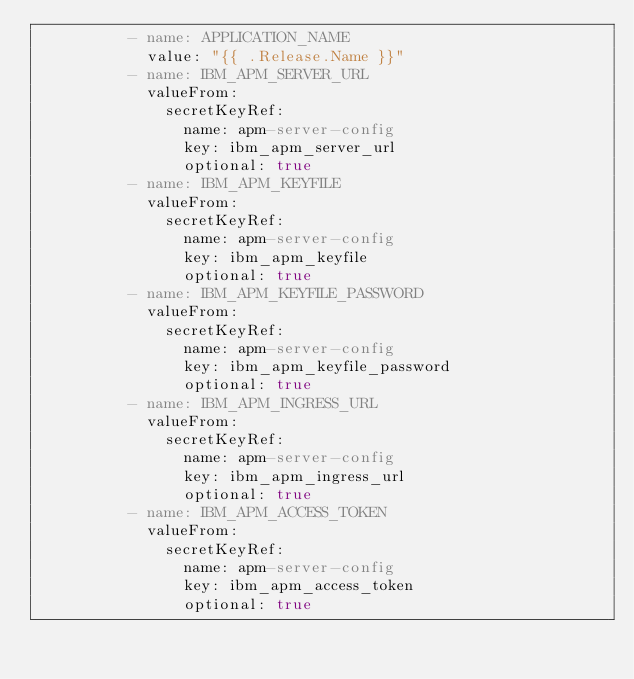<code> <loc_0><loc_0><loc_500><loc_500><_YAML_>          - name: APPLICATION_NAME
            value: "{{ .Release.Name }}"
          - name: IBM_APM_SERVER_URL
            valueFrom:
              secretKeyRef:
                name: apm-server-config
                key: ibm_apm_server_url
                optional: true
          - name: IBM_APM_KEYFILE
            valueFrom:
              secretKeyRef:
                name: apm-server-config
                key: ibm_apm_keyfile
                optional: true
          - name: IBM_APM_KEYFILE_PASSWORD
            valueFrom:
              secretKeyRef:
                name: apm-server-config
                key: ibm_apm_keyfile_password
                optional: true
          - name: IBM_APM_INGRESS_URL
            valueFrom:
              secretKeyRef:
                name: apm-server-config
                key: ibm_apm_ingress_url
                optional: true
          - name: IBM_APM_ACCESS_TOKEN
            valueFrom:
              secretKeyRef:
                name: apm-server-config
                key: ibm_apm_access_token
                optional: true
</code> 